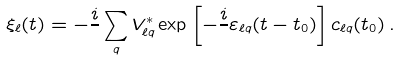<formula> <loc_0><loc_0><loc_500><loc_500>\xi _ { \ell } ( t ) = - \frac { i } { } \sum _ { q } V ^ { * } _ { \ell q } \exp \left [ - \frac { i } { } \varepsilon _ { \ell q } ( t - t _ { 0 } ) \right ] c _ { \ell q } ( t _ { 0 } ) \, .</formula> 